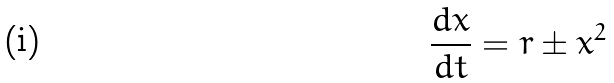<formula> <loc_0><loc_0><loc_500><loc_500>\frac { d x } { d t } = r \pm x ^ { 2 }</formula> 